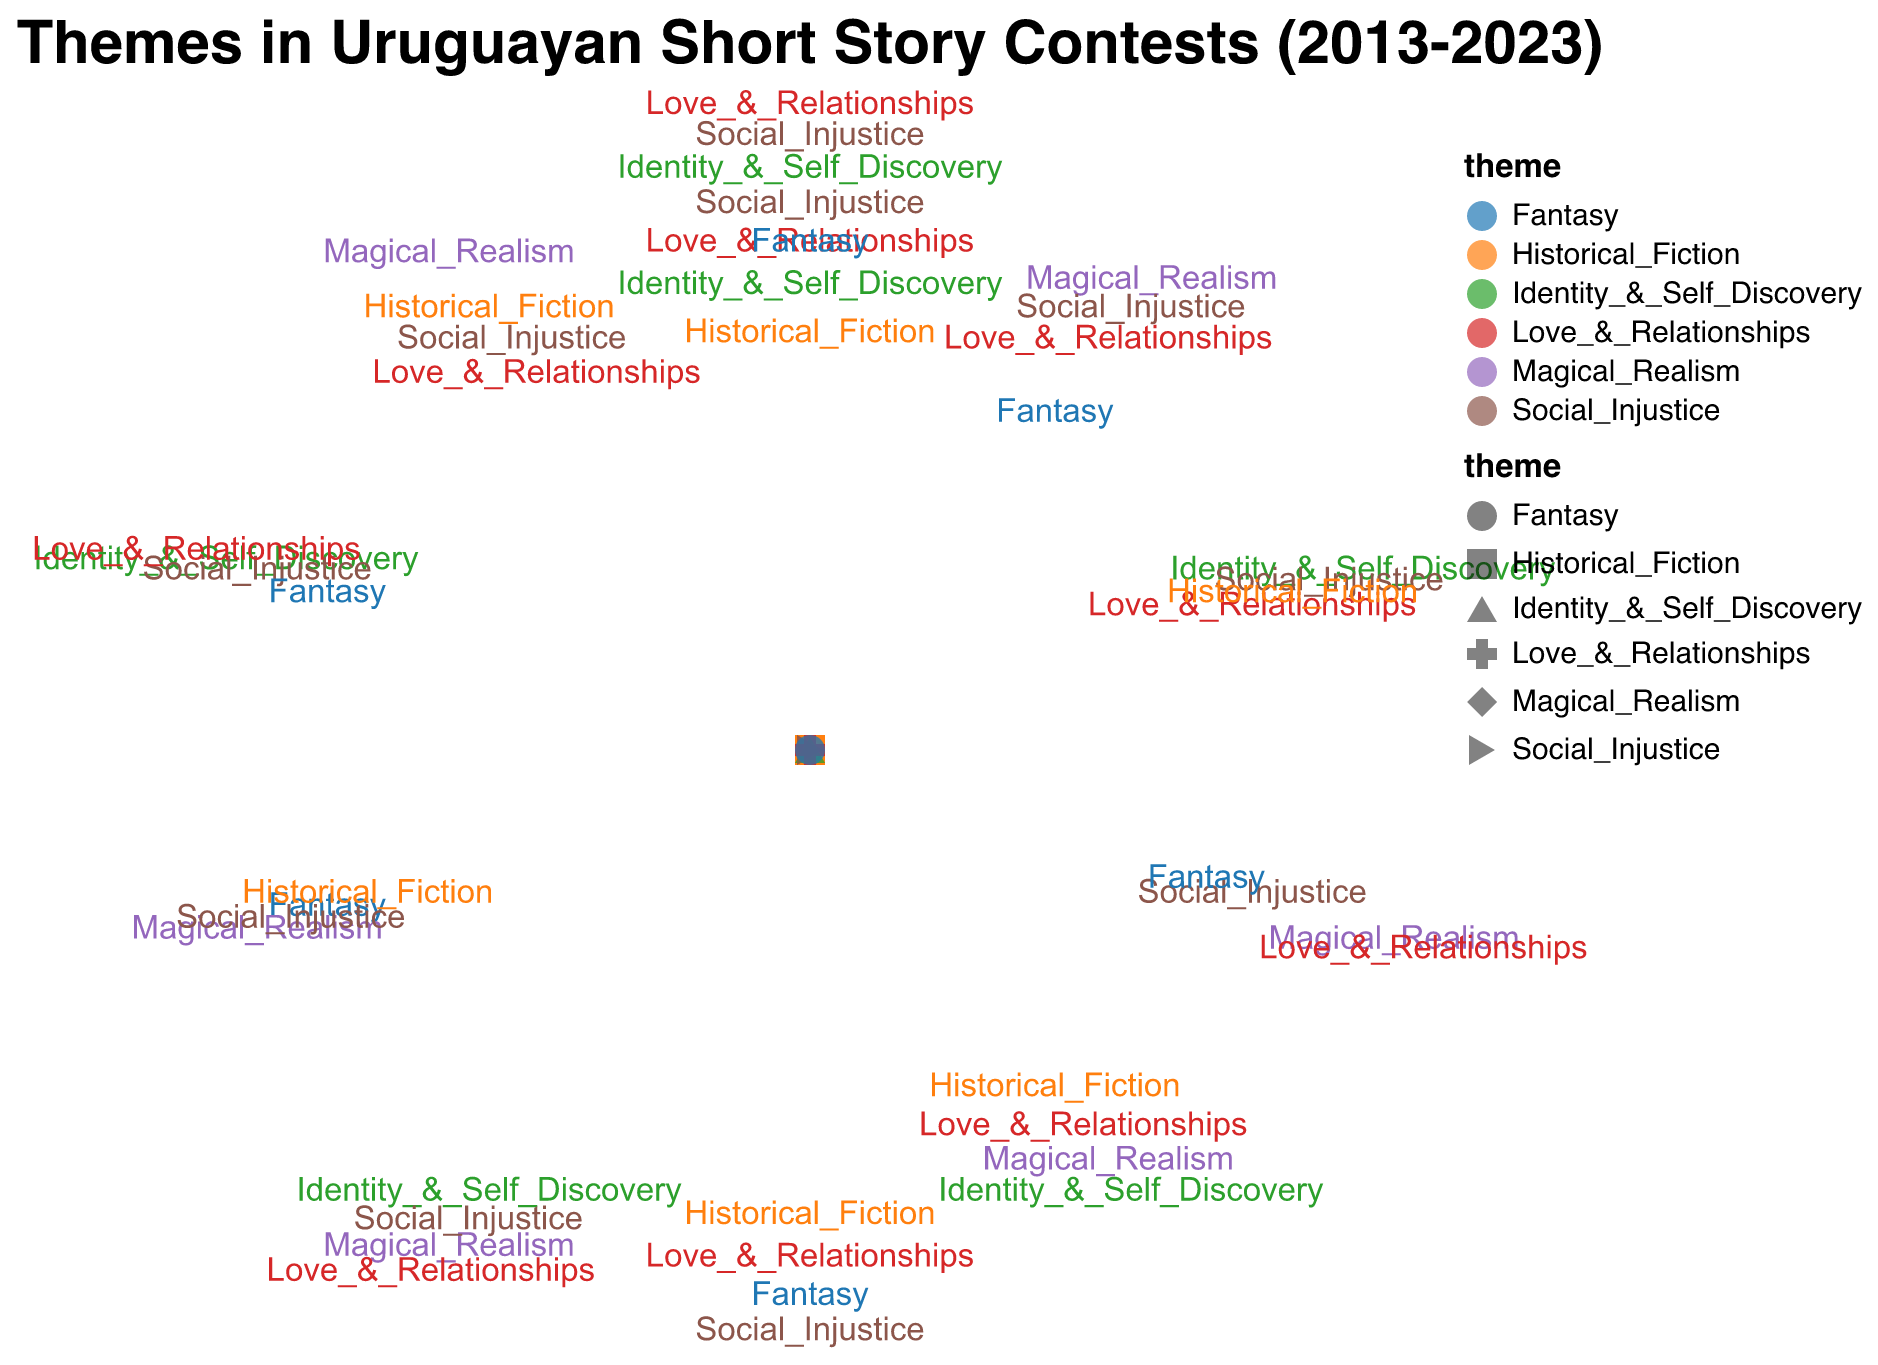What is the theme with the highest number of winning entries in 2016? The color and shape encoding the themes that year show that "Love_&_Relationships" has the largest radius on the Polar Scatter Chart for 2016.
Answer: Love_&_Relationships Which theme had the second highest winning entries in 2017? The Polar Scatter Chart for 2017 shows the radius representing "Identity_&_Self_Discovery" is larger than other themes except "Love_&_Relationships".
Answer: Identity_&_Self_Discovery How has the popularity of "Magical_Realism" changed over the years shown? To understand the trend, observe the radius size representing "Magical_Realism" from 2014 to 2022. The number of entries has increased from 7 in 2014, reached a high of 8 in some years, and consistently maintained a high level across the timeframe.
Answer: It has been consistently popular with slight increases Between "Social_Injustice" and "Historical_Fiction," which theme had more winning entries in 2022? By comparing the radius size for both themes in 2022, "Historical_Fiction" has 6 entries while "Social_Injustice" has 5.
Answer: Historical_Fiction What is the trend for the "Fantasy" theme's winning entries from 2014 to 2023? Check the radius sizes for "Fantasy" from 2014 to 2023. It starts with 3 in 2014. The entries increase and peak at 6 in 2018, then continue with some fluctuation and end with 5 in 2023.
Answer: Increasing then fluctuating Which theme had the highest number of winning entries in 2021, and how many were there? Observing the radii for 2021, "Love_&_Relationships" has the largest radius with 9 winning entries.
Answer: Love_&_Relationships, 9 What theme has shown consistency in winning entries across all years from 2013 to 2023? Reviewing the radii for each theme over the years, "Love_&_Relationships" frequently appears with strong presence consistently.
Answer: Love_&_Relationships How many winning entries did "Identity_&_Self_Discovery" have in 2013 compared to 2023? By observing the radius size for "Identity_&_Self_Discovery" in both years, it had 4 entries in 2013 and increased to 7 entries in 2023.
Answer: 4 in 2013, 7 in 2023 Which theme had the lowest winning entries in 2015, and how many were there? In 2015, "Historical_Fiction" has the smallest radius size indicating 3 winning entries.
Answer: Historical_Fiction, 3 How does the winning entries count for "Social_Injustice" in 2020 compare to its count in 2013? Comparing the radii sizes for "Social_Injustice" in 2020 and 2013, it shows 6 entries in 2020 versus 8 entries in 2013, indicating a decrease.
Answer: 6 in 2020, 8 in 2013 